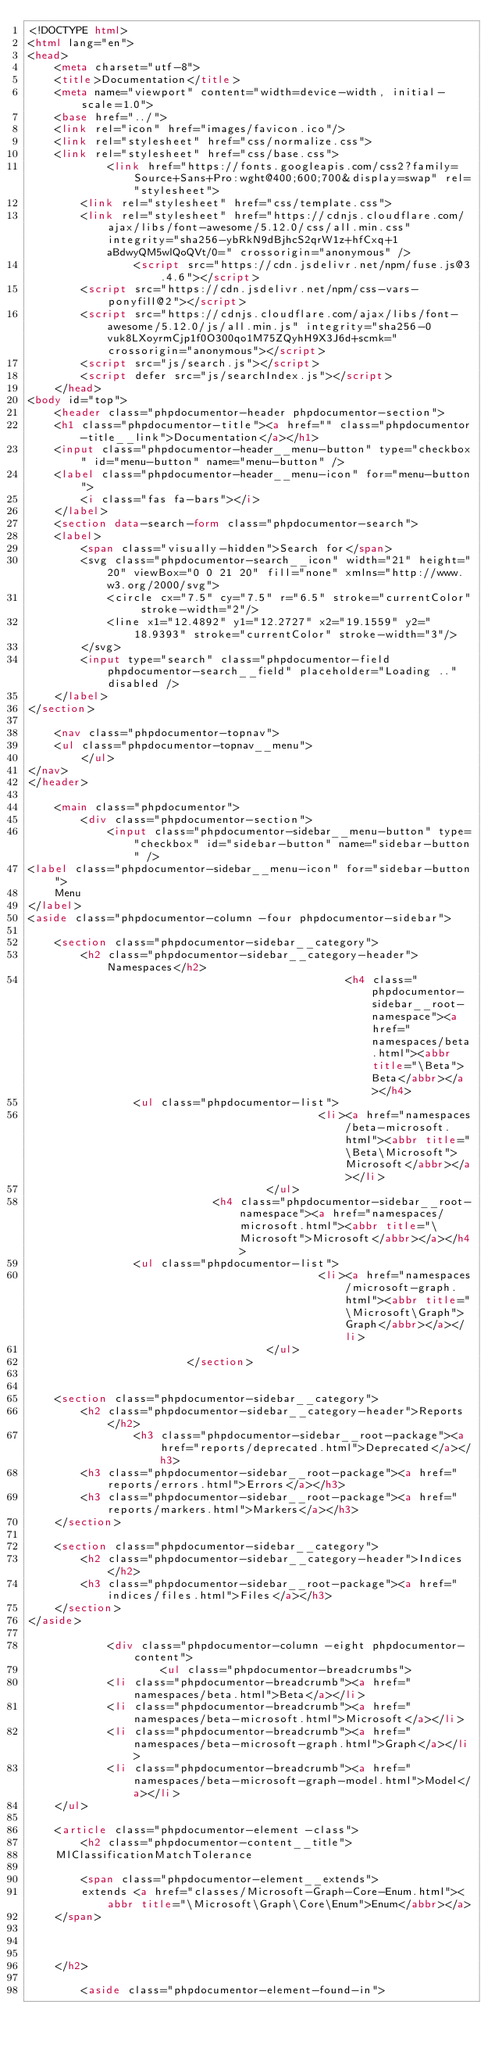<code> <loc_0><loc_0><loc_500><loc_500><_HTML_><!DOCTYPE html>
<html lang="en">
<head>
    <meta charset="utf-8">
    <title>Documentation</title>
    <meta name="viewport" content="width=device-width, initial-scale=1.0">
    <base href="../">
    <link rel="icon" href="images/favicon.ico"/>
    <link rel="stylesheet" href="css/normalize.css">
    <link rel="stylesheet" href="css/base.css">
            <link href="https://fonts.googleapis.com/css2?family=Source+Sans+Pro:wght@400;600;700&display=swap" rel="stylesheet">
        <link rel="stylesheet" href="css/template.css">
        <link rel="stylesheet" href="https://cdnjs.cloudflare.com/ajax/libs/font-awesome/5.12.0/css/all.min.css" integrity="sha256-ybRkN9dBjhcS2qrW1z+hfCxq+1aBdwyQM5wlQoQVt/0=" crossorigin="anonymous" />
                <script src="https://cdn.jsdelivr.net/npm/fuse.js@3.4.6"></script>
        <script src="https://cdn.jsdelivr.net/npm/css-vars-ponyfill@2"></script>
        <script src="https://cdnjs.cloudflare.com/ajax/libs/font-awesome/5.12.0/js/all.min.js" integrity="sha256-0vuk8LXoyrmCjp1f0O300qo1M75ZQyhH9X3J6d+scmk=" crossorigin="anonymous"></script>
        <script src="js/search.js"></script>
        <script defer src="js/searchIndex.js"></script>
    </head>
<body id="top">
    <header class="phpdocumentor-header phpdocumentor-section">
    <h1 class="phpdocumentor-title"><a href="" class="phpdocumentor-title__link">Documentation</a></h1>
    <input class="phpdocumentor-header__menu-button" type="checkbox" id="menu-button" name="menu-button" />
    <label class="phpdocumentor-header__menu-icon" for="menu-button">
        <i class="fas fa-bars"></i>
    </label>
    <section data-search-form class="phpdocumentor-search">
    <label>
        <span class="visually-hidden">Search for</span>
        <svg class="phpdocumentor-search__icon" width="21" height="20" viewBox="0 0 21 20" fill="none" xmlns="http://www.w3.org/2000/svg">
            <circle cx="7.5" cy="7.5" r="6.5" stroke="currentColor" stroke-width="2"/>
            <line x1="12.4892" y1="12.2727" x2="19.1559" y2="18.9393" stroke="currentColor" stroke-width="3"/>
        </svg>
        <input type="search" class="phpdocumentor-field phpdocumentor-search__field" placeholder="Loading .." disabled />
    </label>
</section>

    <nav class="phpdocumentor-topnav">
    <ul class="phpdocumentor-topnav__menu">
        </ul>
</nav>
</header>

    <main class="phpdocumentor">
        <div class="phpdocumentor-section">
            <input class="phpdocumentor-sidebar__menu-button" type="checkbox" id="sidebar-button" name="sidebar-button" />
<label class="phpdocumentor-sidebar__menu-icon" for="sidebar-button">
    Menu
</label>
<aside class="phpdocumentor-column -four phpdocumentor-sidebar">
    
    <section class="phpdocumentor-sidebar__category">
        <h2 class="phpdocumentor-sidebar__category-header">Namespaces</h2>
                                                <h4 class="phpdocumentor-sidebar__root-namespace"><a href="namespaces/beta.html"><abbr title="\Beta">Beta</abbr></a></h4>
                <ul class="phpdocumentor-list">
                                            <li><a href="namespaces/beta-microsoft.html"><abbr title="\Beta\Microsoft">Microsoft</abbr></a></li>
                                    </ul>
                            <h4 class="phpdocumentor-sidebar__root-namespace"><a href="namespaces/microsoft.html"><abbr title="\Microsoft">Microsoft</abbr></a></h4>
                <ul class="phpdocumentor-list">
                                            <li><a href="namespaces/microsoft-graph.html"><abbr title="\Microsoft\Graph">Graph</abbr></a></li>
                                    </ul>
                        </section>

    
    <section class="phpdocumentor-sidebar__category">
        <h2 class="phpdocumentor-sidebar__category-header">Reports</h2>
                <h3 class="phpdocumentor-sidebar__root-package"><a href="reports/deprecated.html">Deprecated</a></h3>
        <h3 class="phpdocumentor-sidebar__root-package"><a href="reports/errors.html">Errors</a></h3>
        <h3 class="phpdocumentor-sidebar__root-package"><a href="reports/markers.html">Markers</a></h3>
    </section>

    <section class="phpdocumentor-sidebar__category">
        <h2 class="phpdocumentor-sidebar__category-header">Indices</h2>
        <h3 class="phpdocumentor-sidebar__root-package"><a href="indices/files.html">Files</a></h3>
    </section>
</aside>

            <div class="phpdocumentor-column -eight phpdocumentor-content">
                    <ul class="phpdocumentor-breadcrumbs">
            <li class="phpdocumentor-breadcrumb"><a href="namespaces/beta.html">Beta</a></li>
            <li class="phpdocumentor-breadcrumb"><a href="namespaces/beta-microsoft.html">Microsoft</a></li>
            <li class="phpdocumentor-breadcrumb"><a href="namespaces/beta-microsoft-graph.html">Graph</a></li>
            <li class="phpdocumentor-breadcrumb"><a href="namespaces/beta-microsoft-graph-model.html">Model</a></li>
    </ul>

    <article class="phpdocumentor-element -class">
        <h2 class="phpdocumentor-content__title">
    MlClassificationMatchTolerance

        <span class="phpdocumentor-element__extends">
        extends <a href="classes/Microsoft-Graph-Core-Enum.html"><abbr title="\Microsoft\Graph\Core\Enum">Enum</abbr></a>
    </span>
    
    
    
    </h2>

        <aside class="phpdocumentor-element-found-in"></code> 